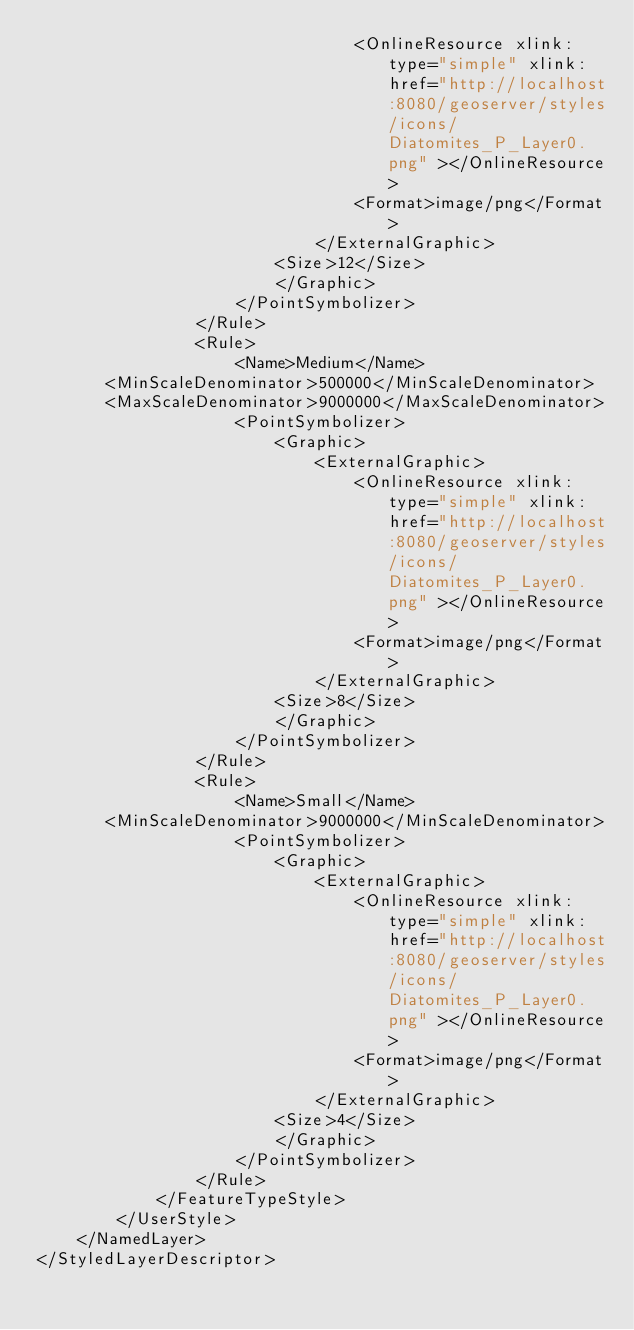<code> <loc_0><loc_0><loc_500><loc_500><_Scheme_>								<OnlineResource xlink:type="simple" xlink:href="http://localhost:8080/geoserver/styles/icons/Diatomites_P_Layer0.png" ></OnlineResource>
								<Format>image/png</Format>
							</ExternalGraphic>
                        <Size>12</Size>
						</Graphic>
					</PointSymbolizer>
				</Rule>
				<Rule>
                    <Name>Medium</Name>
       <MinScaleDenominator>500000</MinScaleDenominator>
       <MaxScaleDenominator>9000000</MaxScaleDenominator>
					<PointSymbolizer>
						<Graphic>
							<ExternalGraphic>
								<OnlineResource xlink:type="simple" xlink:href="http://localhost:8080/geoserver/styles/icons/Diatomites_P_Layer0.png" ></OnlineResource>
								<Format>image/png</Format>
							</ExternalGraphic>
                        <Size>8</Size>
						</Graphic>
					</PointSymbolizer>
				</Rule>
				<Rule>
                    <Name>Small</Name>
       <MinScaleDenominator>9000000</MinScaleDenominator>
					<PointSymbolizer>
						<Graphic>
							<ExternalGraphic>
								<OnlineResource xlink:type="simple" xlink:href="http://localhost:8080/geoserver/styles/icons/Diatomites_P_Layer0.png" ></OnlineResource>
								<Format>image/png</Format>
							</ExternalGraphic>
                        <Size>4</Size>
						</Graphic>
					</PointSymbolizer>
				</Rule>
			</FeatureTypeStyle>
		</UserStyle>
	</NamedLayer>
</StyledLayerDescriptor></code> 